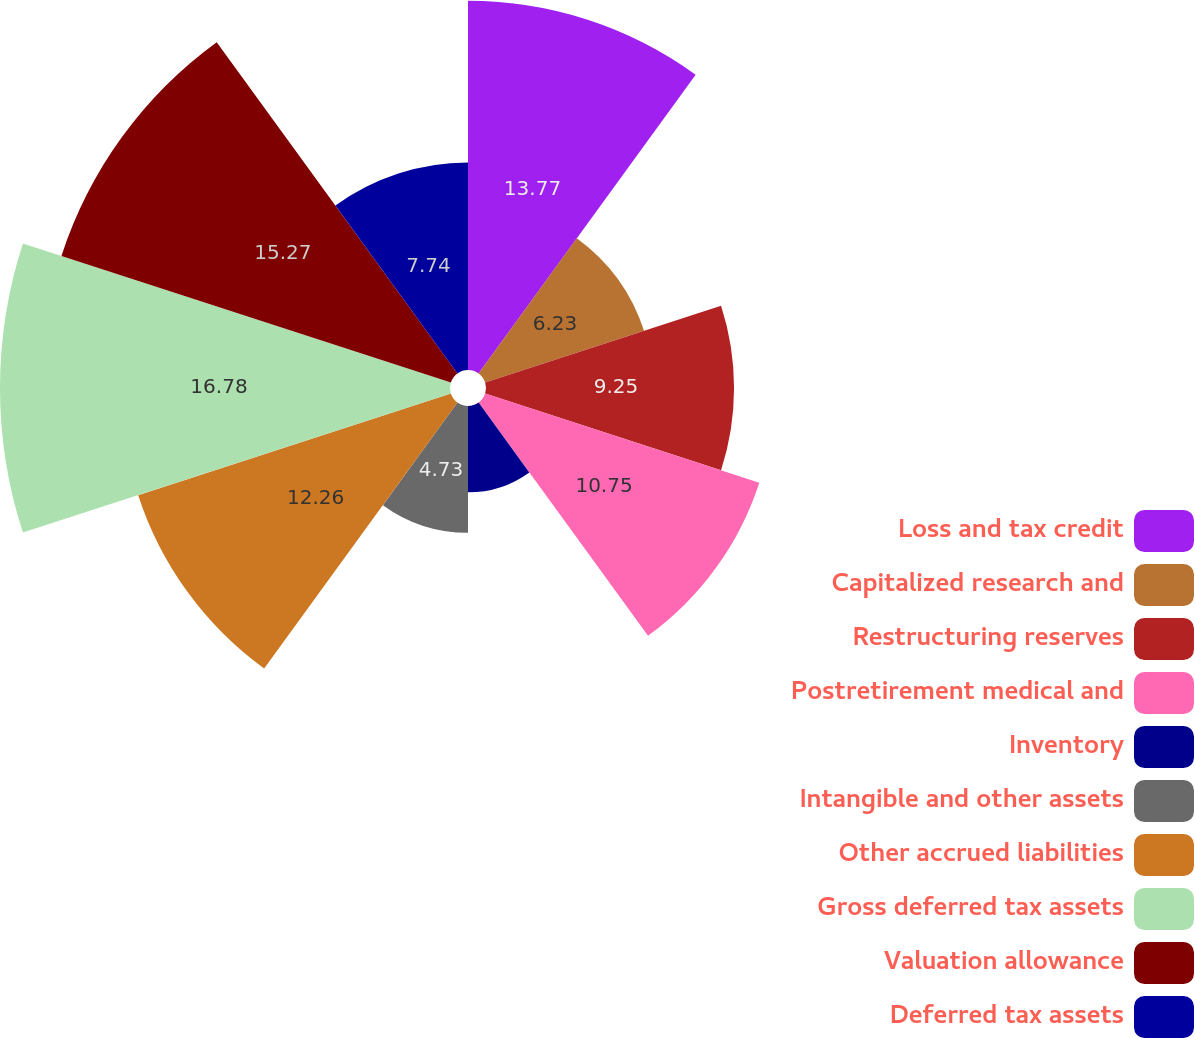Convert chart to OTSL. <chart><loc_0><loc_0><loc_500><loc_500><pie_chart><fcel>Loss and tax credit<fcel>Capitalized research and<fcel>Restructuring reserves<fcel>Postretirement medical and<fcel>Inventory<fcel>Intangible and other assets<fcel>Other accrued liabilities<fcel>Gross deferred tax assets<fcel>Valuation allowance<fcel>Deferred tax assets<nl><fcel>13.77%<fcel>6.23%<fcel>9.25%<fcel>10.75%<fcel>3.22%<fcel>4.73%<fcel>12.26%<fcel>16.78%<fcel>15.27%<fcel>7.74%<nl></chart> 